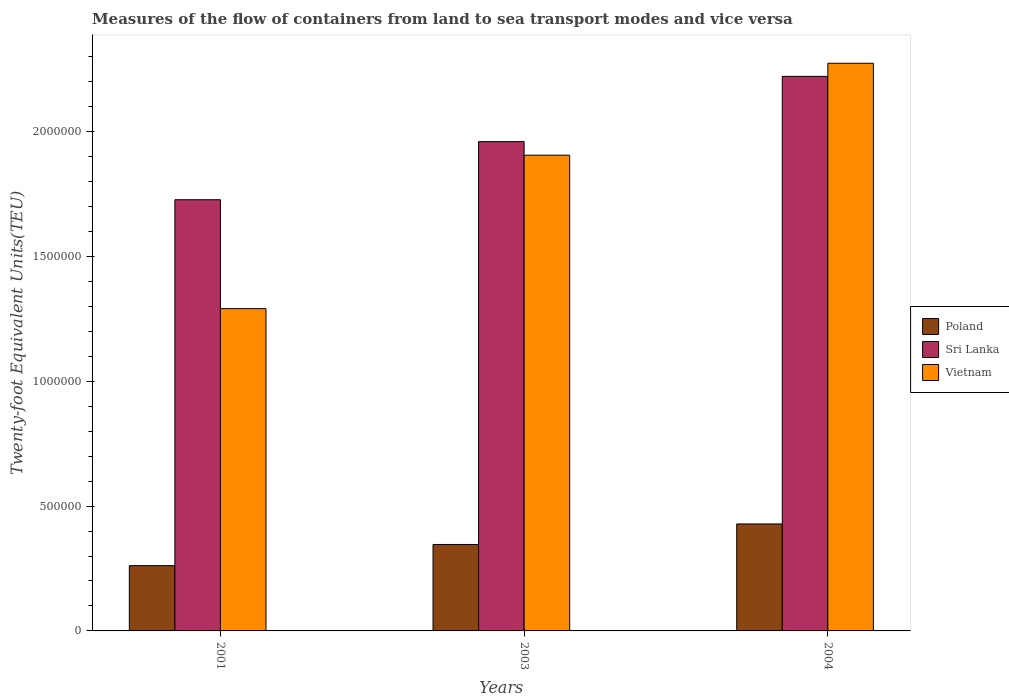How many different coloured bars are there?
Provide a succinct answer. 3. How many groups of bars are there?
Offer a terse response. 3. Are the number of bars per tick equal to the number of legend labels?
Provide a succinct answer. Yes. Are the number of bars on each tick of the X-axis equal?
Your response must be concise. Yes. How many bars are there on the 1st tick from the right?
Your answer should be very brief. 3. What is the container port traffic in Sri Lanka in 2001?
Make the answer very short. 1.73e+06. Across all years, what is the maximum container port traffic in Vietnam?
Your answer should be compact. 2.27e+06. Across all years, what is the minimum container port traffic in Poland?
Your response must be concise. 2.61e+05. In which year was the container port traffic in Sri Lanka maximum?
Keep it short and to the point. 2004. In which year was the container port traffic in Vietnam minimum?
Your answer should be compact. 2001. What is the total container port traffic in Vietnam in the graph?
Ensure brevity in your answer.  5.47e+06. What is the difference between the container port traffic in Vietnam in 2001 and that in 2004?
Offer a very short reply. -9.83e+05. What is the difference between the container port traffic in Vietnam in 2001 and the container port traffic in Poland in 2004?
Provide a succinct answer. 8.62e+05. What is the average container port traffic in Vietnam per year?
Give a very brief answer. 1.82e+06. In the year 2003, what is the difference between the container port traffic in Vietnam and container port traffic in Sri Lanka?
Your answer should be very brief. -5.44e+04. What is the ratio of the container port traffic in Vietnam in 2001 to that in 2004?
Offer a very short reply. 0.57. Is the difference between the container port traffic in Vietnam in 2003 and 2004 greater than the difference between the container port traffic in Sri Lanka in 2003 and 2004?
Give a very brief answer. No. What is the difference between the highest and the second highest container port traffic in Sri Lanka?
Keep it short and to the point. 2.61e+05. What is the difference between the highest and the lowest container port traffic in Sri Lanka?
Ensure brevity in your answer.  4.94e+05. What does the 1st bar from the left in 2003 represents?
Provide a short and direct response. Poland. What does the 2nd bar from the right in 2004 represents?
Your answer should be very brief. Sri Lanka. Is it the case that in every year, the sum of the container port traffic in Sri Lanka and container port traffic in Poland is greater than the container port traffic in Vietnam?
Keep it short and to the point. Yes. How many bars are there?
Ensure brevity in your answer.  9. Are all the bars in the graph horizontal?
Your answer should be very brief. No. How many years are there in the graph?
Ensure brevity in your answer.  3. What is the difference between two consecutive major ticks on the Y-axis?
Make the answer very short. 5.00e+05. Are the values on the major ticks of Y-axis written in scientific E-notation?
Your answer should be compact. No. Does the graph contain any zero values?
Offer a terse response. No. How are the legend labels stacked?
Keep it short and to the point. Vertical. What is the title of the graph?
Keep it short and to the point. Measures of the flow of containers from land to sea transport modes and vice versa. What is the label or title of the X-axis?
Make the answer very short. Years. What is the label or title of the Y-axis?
Offer a terse response. Twenty-foot Equivalent Units(TEU). What is the Twenty-foot Equivalent Units(TEU) in Poland in 2001?
Provide a succinct answer. 2.61e+05. What is the Twenty-foot Equivalent Units(TEU) in Sri Lanka in 2001?
Offer a terse response. 1.73e+06. What is the Twenty-foot Equivalent Units(TEU) of Vietnam in 2001?
Keep it short and to the point. 1.29e+06. What is the Twenty-foot Equivalent Units(TEU) in Poland in 2003?
Your response must be concise. 3.46e+05. What is the Twenty-foot Equivalent Units(TEU) of Sri Lanka in 2003?
Ensure brevity in your answer.  1.96e+06. What is the Twenty-foot Equivalent Units(TEU) of Vietnam in 2003?
Your answer should be very brief. 1.90e+06. What is the Twenty-foot Equivalent Units(TEU) in Poland in 2004?
Your answer should be very brief. 4.28e+05. What is the Twenty-foot Equivalent Units(TEU) of Sri Lanka in 2004?
Your answer should be compact. 2.22e+06. What is the Twenty-foot Equivalent Units(TEU) in Vietnam in 2004?
Give a very brief answer. 2.27e+06. Across all years, what is the maximum Twenty-foot Equivalent Units(TEU) in Poland?
Your answer should be compact. 4.28e+05. Across all years, what is the maximum Twenty-foot Equivalent Units(TEU) of Sri Lanka?
Make the answer very short. 2.22e+06. Across all years, what is the maximum Twenty-foot Equivalent Units(TEU) in Vietnam?
Offer a very short reply. 2.27e+06. Across all years, what is the minimum Twenty-foot Equivalent Units(TEU) of Poland?
Offer a very short reply. 2.61e+05. Across all years, what is the minimum Twenty-foot Equivalent Units(TEU) of Sri Lanka?
Keep it short and to the point. 1.73e+06. Across all years, what is the minimum Twenty-foot Equivalent Units(TEU) in Vietnam?
Provide a succinct answer. 1.29e+06. What is the total Twenty-foot Equivalent Units(TEU) in Poland in the graph?
Your answer should be very brief. 1.04e+06. What is the total Twenty-foot Equivalent Units(TEU) in Sri Lanka in the graph?
Your answer should be very brief. 5.91e+06. What is the total Twenty-foot Equivalent Units(TEU) of Vietnam in the graph?
Your response must be concise. 5.47e+06. What is the difference between the Twenty-foot Equivalent Units(TEU) in Poland in 2001 and that in 2003?
Your response must be concise. -8.47e+04. What is the difference between the Twenty-foot Equivalent Units(TEU) in Sri Lanka in 2001 and that in 2003?
Keep it short and to the point. -2.33e+05. What is the difference between the Twenty-foot Equivalent Units(TEU) of Vietnam in 2001 and that in 2003?
Keep it short and to the point. -6.14e+05. What is the difference between the Twenty-foot Equivalent Units(TEU) in Poland in 2001 and that in 2004?
Give a very brief answer. -1.67e+05. What is the difference between the Twenty-foot Equivalent Units(TEU) in Sri Lanka in 2001 and that in 2004?
Offer a terse response. -4.94e+05. What is the difference between the Twenty-foot Equivalent Units(TEU) of Vietnam in 2001 and that in 2004?
Keep it short and to the point. -9.83e+05. What is the difference between the Twenty-foot Equivalent Units(TEU) of Poland in 2003 and that in 2004?
Ensure brevity in your answer.  -8.22e+04. What is the difference between the Twenty-foot Equivalent Units(TEU) of Sri Lanka in 2003 and that in 2004?
Your answer should be compact. -2.61e+05. What is the difference between the Twenty-foot Equivalent Units(TEU) of Vietnam in 2003 and that in 2004?
Offer a terse response. -3.68e+05. What is the difference between the Twenty-foot Equivalent Units(TEU) in Poland in 2001 and the Twenty-foot Equivalent Units(TEU) in Sri Lanka in 2003?
Provide a succinct answer. -1.70e+06. What is the difference between the Twenty-foot Equivalent Units(TEU) in Poland in 2001 and the Twenty-foot Equivalent Units(TEU) in Vietnam in 2003?
Make the answer very short. -1.64e+06. What is the difference between the Twenty-foot Equivalent Units(TEU) of Sri Lanka in 2001 and the Twenty-foot Equivalent Units(TEU) of Vietnam in 2003?
Ensure brevity in your answer.  -1.78e+05. What is the difference between the Twenty-foot Equivalent Units(TEU) of Poland in 2001 and the Twenty-foot Equivalent Units(TEU) of Sri Lanka in 2004?
Ensure brevity in your answer.  -1.96e+06. What is the difference between the Twenty-foot Equivalent Units(TEU) in Poland in 2001 and the Twenty-foot Equivalent Units(TEU) in Vietnam in 2004?
Make the answer very short. -2.01e+06. What is the difference between the Twenty-foot Equivalent Units(TEU) of Sri Lanka in 2001 and the Twenty-foot Equivalent Units(TEU) of Vietnam in 2004?
Provide a short and direct response. -5.46e+05. What is the difference between the Twenty-foot Equivalent Units(TEU) of Poland in 2003 and the Twenty-foot Equivalent Units(TEU) of Sri Lanka in 2004?
Your answer should be very brief. -1.87e+06. What is the difference between the Twenty-foot Equivalent Units(TEU) of Poland in 2003 and the Twenty-foot Equivalent Units(TEU) of Vietnam in 2004?
Keep it short and to the point. -1.93e+06. What is the difference between the Twenty-foot Equivalent Units(TEU) of Sri Lanka in 2003 and the Twenty-foot Equivalent Units(TEU) of Vietnam in 2004?
Ensure brevity in your answer.  -3.14e+05. What is the average Twenty-foot Equivalent Units(TEU) of Poland per year?
Offer a terse response. 3.45e+05. What is the average Twenty-foot Equivalent Units(TEU) of Sri Lanka per year?
Offer a very short reply. 1.97e+06. What is the average Twenty-foot Equivalent Units(TEU) in Vietnam per year?
Provide a short and direct response. 1.82e+06. In the year 2001, what is the difference between the Twenty-foot Equivalent Units(TEU) in Poland and Twenty-foot Equivalent Units(TEU) in Sri Lanka?
Provide a short and direct response. -1.47e+06. In the year 2001, what is the difference between the Twenty-foot Equivalent Units(TEU) of Poland and Twenty-foot Equivalent Units(TEU) of Vietnam?
Your answer should be very brief. -1.03e+06. In the year 2001, what is the difference between the Twenty-foot Equivalent Units(TEU) of Sri Lanka and Twenty-foot Equivalent Units(TEU) of Vietnam?
Offer a very short reply. 4.36e+05. In the year 2003, what is the difference between the Twenty-foot Equivalent Units(TEU) in Poland and Twenty-foot Equivalent Units(TEU) in Sri Lanka?
Provide a succinct answer. -1.61e+06. In the year 2003, what is the difference between the Twenty-foot Equivalent Units(TEU) in Poland and Twenty-foot Equivalent Units(TEU) in Vietnam?
Your response must be concise. -1.56e+06. In the year 2003, what is the difference between the Twenty-foot Equivalent Units(TEU) of Sri Lanka and Twenty-foot Equivalent Units(TEU) of Vietnam?
Provide a succinct answer. 5.44e+04. In the year 2004, what is the difference between the Twenty-foot Equivalent Units(TEU) in Poland and Twenty-foot Equivalent Units(TEU) in Sri Lanka?
Make the answer very short. -1.79e+06. In the year 2004, what is the difference between the Twenty-foot Equivalent Units(TEU) of Poland and Twenty-foot Equivalent Units(TEU) of Vietnam?
Your answer should be very brief. -1.84e+06. In the year 2004, what is the difference between the Twenty-foot Equivalent Units(TEU) of Sri Lanka and Twenty-foot Equivalent Units(TEU) of Vietnam?
Provide a succinct answer. -5.25e+04. What is the ratio of the Twenty-foot Equivalent Units(TEU) in Poland in 2001 to that in 2003?
Offer a terse response. 0.76. What is the ratio of the Twenty-foot Equivalent Units(TEU) of Sri Lanka in 2001 to that in 2003?
Provide a short and direct response. 0.88. What is the ratio of the Twenty-foot Equivalent Units(TEU) in Vietnam in 2001 to that in 2003?
Offer a very short reply. 0.68. What is the ratio of the Twenty-foot Equivalent Units(TEU) of Poland in 2001 to that in 2004?
Make the answer very short. 0.61. What is the ratio of the Twenty-foot Equivalent Units(TEU) of Sri Lanka in 2001 to that in 2004?
Your response must be concise. 0.78. What is the ratio of the Twenty-foot Equivalent Units(TEU) in Vietnam in 2001 to that in 2004?
Offer a very short reply. 0.57. What is the ratio of the Twenty-foot Equivalent Units(TEU) in Poland in 2003 to that in 2004?
Your answer should be very brief. 0.81. What is the ratio of the Twenty-foot Equivalent Units(TEU) of Sri Lanka in 2003 to that in 2004?
Offer a terse response. 0.88. What is the ratio of the Twenty-foot Equivalent Units(TEU) of Vietnam in 2003 to that in 2004?
Your answer should be very brief. 0.84. What is the difference between the highest and the second highest Twenty-foot Equivalent Units(TEU) of Poland?
Ensure brevity in your answer.  8.22e+04. What is the difference between the highest and the second highest Twenty-foot Equivalent Units(TEU) of Sri Lanka?
Your answer should be very brief. 2.61e+05. What is the difference between the highest and the second highest Twenty-foot Equivalent Units(TEU) in Vietnam?
Make the answer very short. 3.68e+05. What is the difference between the highest and the lowest Twenty-foot Equivalent Units(TEU) of Poland?
Offer a very short reply. 1.67e+05. What is the difference between the highest and the lowest Twenty-foot Equivalent Units(TEU) of Sri Lanka?
Ensure brevity in your answer.  4.94e+05. What is the difference between the highest and the lowest Twenty-foot Equivalent Units(TEU) of Vietnam?
Offer a terse response. 9.83e+05. 